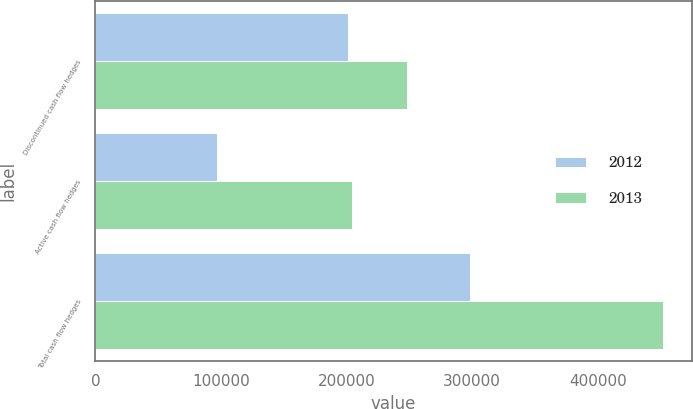Convert chart to OTSL. <chart><loc_0><loc_0><loc_500><loc_500><stacked_bar_chart><ecel><fcel>Discontinued cash flow hedges<fcel>Active cash flow hedges<fcel>Total cash flow hedges<nl><fcel>2012<fcel>201356<fcel>96754<fcel>298110<nl><fcel>2013<fcel>247983<fcel>204358<fcel>452341<nl></chart> 